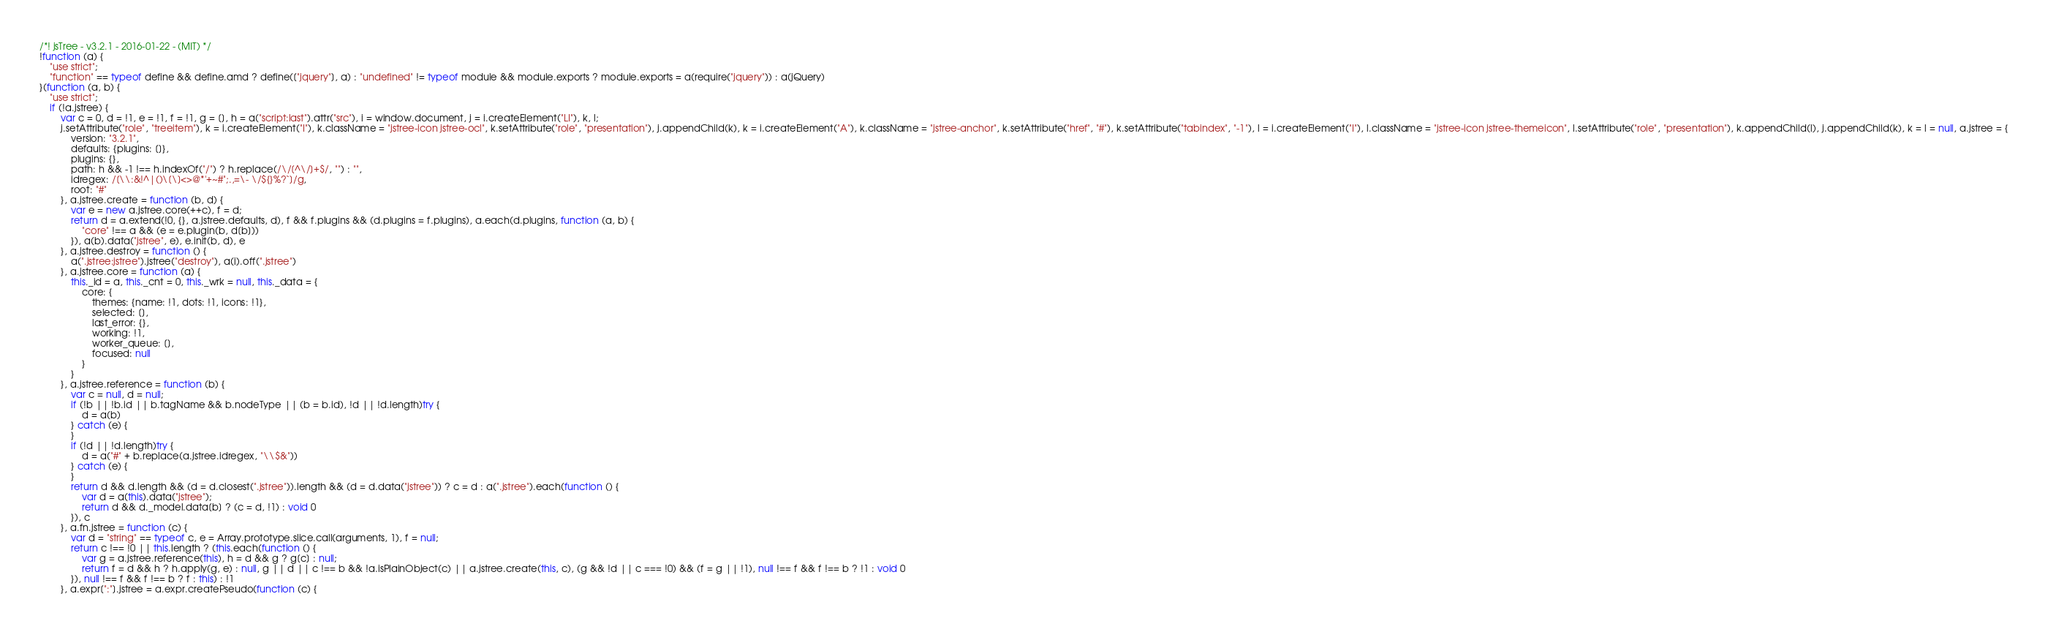Convert code to text. <code><loc_0><loc_0><loc_500><loc_500><_JavaScript_>/*! jsTree - v3.2.1 - 2016-01-22 - (MIT) */
!function (a) {
    "use strict";
    "function" == typeof define && define.amd ? define(["jquery"], a) : "undefined" != typeof module && module.exports ? module.exports = a(require("jquery")) : a(jQuery)
}(function (a, b) {
    "use strict";
    if (!a.jstree) {
        var c = 0, d = !1, e = !1, f = !1, g = [], h = a("script:last").attr("src"), i = window.document, j = i.createElement("LI"), k, l;
        j.setAttribute("role", "treeitem"), k = i.createElement("I"), k.className = "jstree-icon jstree-ocl", k.setAttribute("role", "presentation"), j.appendChild(k), k = i.createElement("A"), k.className = "jstree-anchor", k.setAttribute("href", "#"), k.setAttribute("tabindex", "-1"), l = i.createElement("I"), l.className = "jstree-icon jstree-themeicon", l.setAttribute("role", "presentation"), k.appendChild(l), j.appendChild(k), k = l = null, a.jstree = {
            version: "3.2.1",
            defaults: {plugins: []},
            plugins: {},
            path: h && -1 !== h.indexOf("/") ? h.replace(/\/[^\/]+$/, "") : "",
            idregex: /[\\:&!^|()\[\]<>@*'+~#";.,=\- \/${}%?`]/g,
            root: "#"
        }, a.jstree.create = function (b, d) {
            var e = new a.jstree.core(++c), f = d;
            return d = a.extend(!0, {}, a.jstree.defaults, d), f && f.plugins && (d.plugins = f.plugins), a.each(d.plugins, function (a, b) {
                "core" !== a && (e = e.plugin(b, d[b]))
            }), a(b).data("jstree", e), e.init(b, d), e
        }, a.jstree.destroy = function () {
            a(".jstree:jstree").jstree("destroy"), a(i).off(".jstree")
        }, a.jstree.core = function (a) {
            this._id = a, this._cnt = 0, this._wrk = null, this._data = {
                core: {
                    themes: {name: !1, dots: !1, icons: !1},
                    selected: [],
                    last_error: {},
                    working: !1,
                    worker_queue: [],
                    focused: null
                }
            }
        }, a.jstree.reference = function (b) {
            var c = null, d = null;
            if (!b || !b.id || b.tagName && b.nodeType || (b = b.id), !d || !d.length)try {
                d = a(b)
            } catch (e) {
            }
            if (!d || !d.length)try {
                d = a("#" + b.replace(a.jstree.idregex, "\\$&"))
            } catch (e) {
            }
            return d && d.length && (d = d.closest(".jstree")).length && (d = d.data("jstree")) ? c = d : a(".jstree").each(function () {
                var d = a(this).data("jstree");
                return d && d._model.data[b] ? (c = d, !1) : void 0
            }), c
        }, a.fn.jstree = function (c) {
            var d = "string" == typeof c, e = Array.prototype.slice.call(arguments, 1), f = null;
            return c !== !0 || this.length ? (this.each(function () {
                var g = a.jstree.reference(this), h = d && g ? g[c] : null;
                return f = d && h ? h.apply(g, e) : null, g || d || c !== b && !a.isPlainObject(c) || a.jstree.create(this, c), (g && !d || c === !0) && (f = g || !1), null !== f && f !== b ? !1 : void 0
            }), null !== f && f !== b ? f : this) : !1
        }, a.expr[":"].jstree = a.expr.createPseudo(function (c) {</code> 